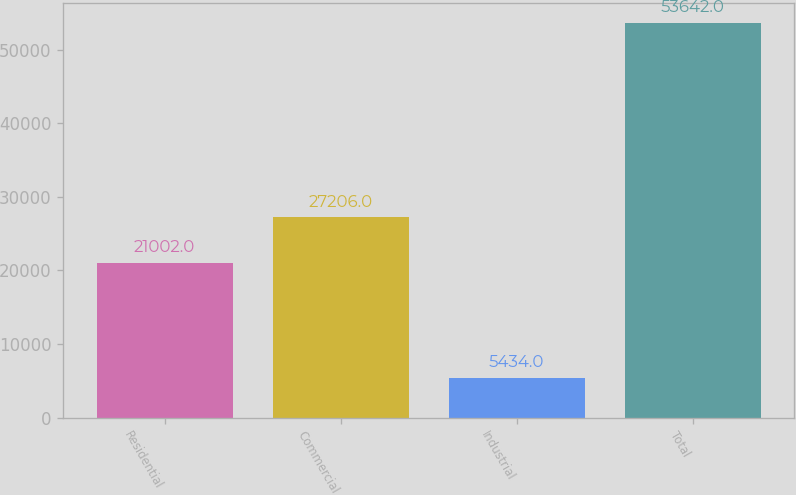<chart> <loc_0><loc_0><loc_500><loc_500><bar_chart><fcel>Residential<fcel>Commercial<fcel>Industrial<fcel>Total<nl><fcel>21002<fcel>27206<fcel>5434<fcel>53642<nl></chart> 